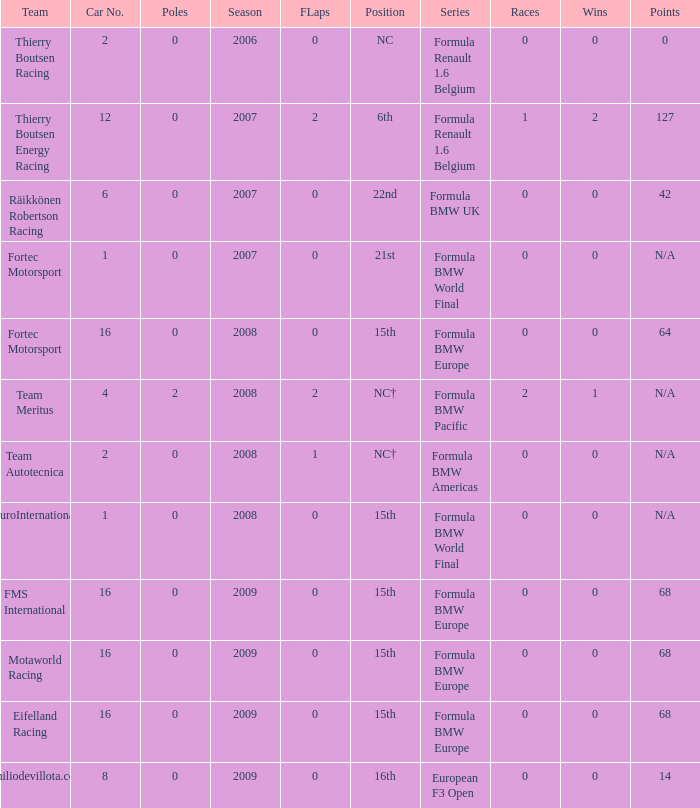Name the position for eifelland racing 15th. 